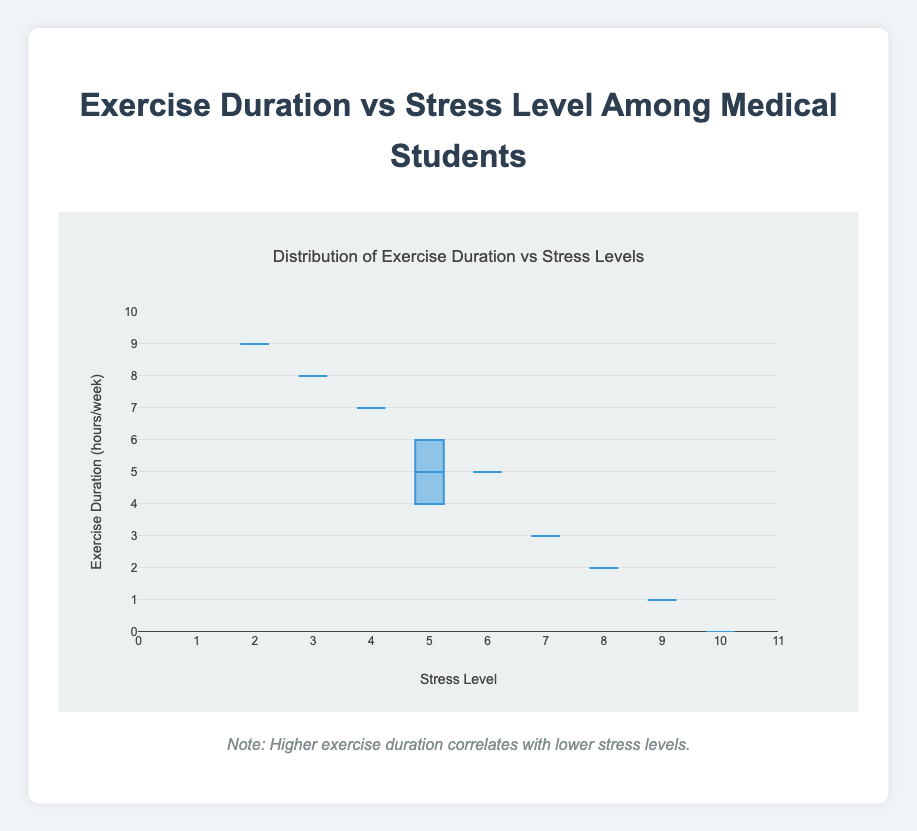What is the title of the plot? The title summarizes the main point of the figure. It is located at the top of the plot.
Answer: Distribution of Exercise Duration vs Stress Levels What is the range of stress levels on the x-axis? To find this, look at the start and end points of the x-axis, which are labeled on both sides.
Answer: 0 to 11 How many data points are shown in the plot? Count the number of data points in the distribution. Each data point represents a student's data.
Answer: 10 What is the median exercise duration in the plot? The median is the value that separates the higher half from the lower half of a data sample. In a box plot, the median is represented by the line inside the box.
Answer: 4.5 hours/week Which student has the highest exercise duration and what is their corresponding stress level? Identify the point on the plot with the highest exercise duration and note its corresponding stress level.
Answer: Linda White (9 hours/week, Stress Level 2) What's the interquartile range (IQR) of exercise duration? The IQR is the range within the box of the box plot. It is calculated by subtracting the first quartile (Q1) from the third quartile (Q3).
Answer: Q3 - Q1 = 6.5 - 2.5 = 4 hours/week How does the median stress level compare to the median exercise duration? Check both medians on their respective axes and compare them.
Answer: Median stress level (6) is higher than the median exercise duration (4.5 hours/week) Is there an obvious outlier in the exercise duration data? Check if any data points fall significantly outside the whiskers of the box plot.
Answer: Yes, the data point at 0 hours/week Based on the plot, what is the general trend between exercise duration and stress level? Observe the spread of data points and the correlation direction between x and y. Higher exercise duration corresponds to lower stress levels, indicating a negative correlation.
Answer: Negative correlation What is the lower quartile (Q1) value for exercise duration? This is the value at the lower edge of the box in the box plot, representing the 25th percentile.
Answer: 2.5 hours/week 